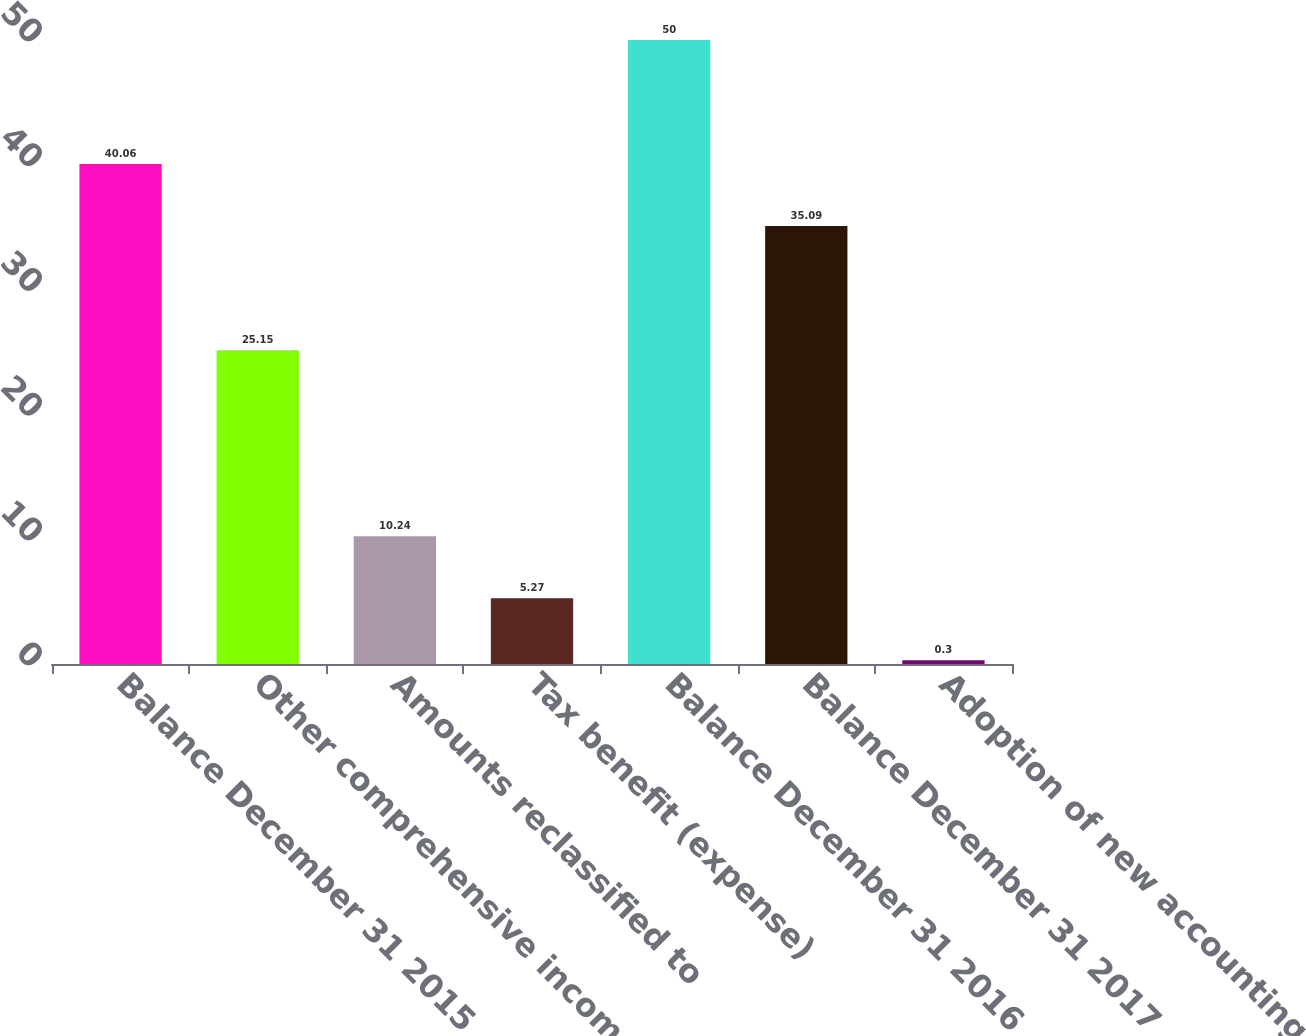Convert chart to OTSL. <chart><loc_0><loc_0><loc_500><loc_500><bar_chart><fcel>Balance December 31 2015<fcel>Other comprehensive income<fcel>Amounts reclassified to<fcel>Tax benefit (expense)<fcel>Balance December 31 2016<fcel>Balance December 31 2017<fcel>Adoption of new accounting<nl><fcel>40.06<fcel>25.15<fcel>10.24<fcel>5.27<fcel>50<fcel>35.09<fcel>0.3<nl></chart> 